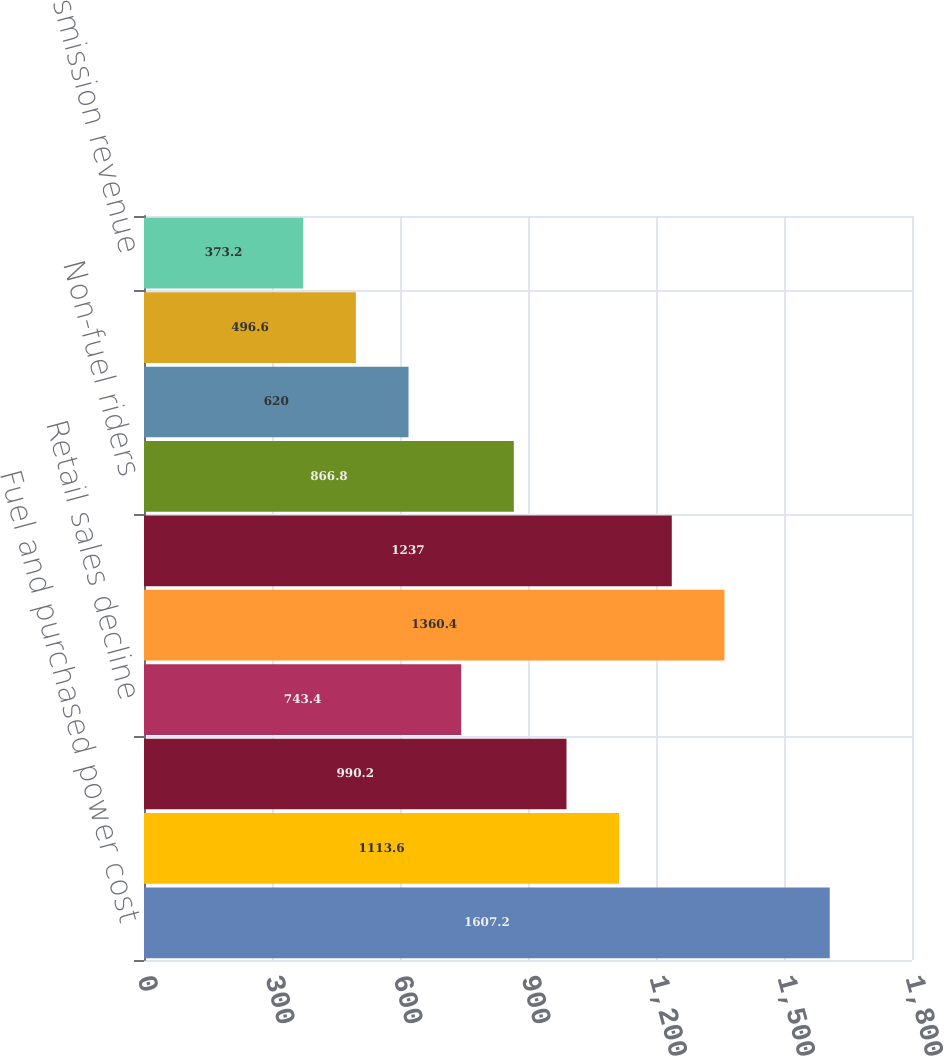Convert chart to OTSL. <chart><loc_0><loc_0><loc_500><loc_500><bar_chart><fcel>Fuel and purchased power cost<fcel>Trading<fcel>Estimated impact of weather<fcel>Retail sales decline<fcel>Retail rate increases<fcel>Conservation and DSM revenue<fcel>Non-fuel riders<fcel>MERP rider<fcel>2008 refund of nuclear<fcel>Transmission revenue<nl><fcel>1607.2<fcel>1113.6<fcel>990.2<fcel>743.4<fcel>1360.4<fcel>1237<fcel>866.8<fcel>620<fcel>496.6<fcel>373.2<nl></chart> 